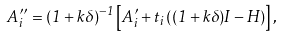<formula> <loc_0><loc_0><loc_500><loc_500>A ^ { \prime \prime } _ { i } = ( 1 + k \delta ) ^ { - 1 } \left [ A ^ { \prime } _ { i } + t _ { i } \left ( ( 1 + k \delta ) I - H \right ) \right ] ,</formula> 